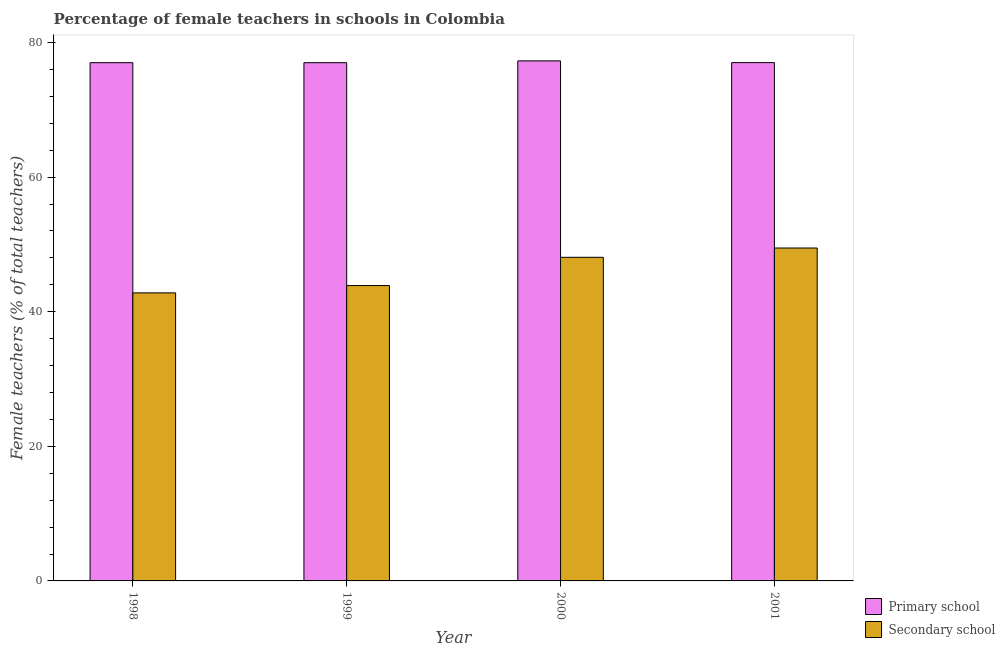How many different coloured bars are there?
Offer a terse response. 2. How many groups of bars are there?
Your response must be concise. 4. Are the number of bars per tick equal to the number of legend labels?
Offer a very short reply. Yes. Are the number of bars on each tick of the X-axis equal?
Provide a short and direct response. Yes. How many bars are there on the 1st tick from the right?
Your response must be concise. 2. What is the percentage of female teachers in primary schools in 2000?
Provide a short and direct response. 77.27. Across all years, what is the maximum percentage of female teachers in secondary schools?
Offer a terse response. 49.47. Across all years, what is the minimum percentage of female teachers in secondary schools?
Offer a terse response. 42.8. What is the total percentage of female teachers in secondary schools in the graph?
Your response must be concise. 184.24. What is the difference between the percentage of female teachers in secondary schools in 1998 and that in 1999?
Offer a terse response. -1.09. What is the difference between the percentage of female teachers in secondary schools in 2001 and the percentage of female teachers in primary schools in 1999?
Provide a succinct answer. 5.58. What is the average percentage of female teachers in secondary schools per year?
Offer a very short reply. 46.06. What is the ratio of the percentage of female teachers in secondary schools in 1998 to that in 1999?
Your response must be concise. 0.98. What is the difference between the highest and the second highest percentage of female teachers in secondary schools?
Your answer should be compact. 1.38. What is the difference between the highest and the lowest percentage of female teachers in primary schools?
Offer a very short reply. 0.27. In how many years, is the percentage of female teachers in primary schools greater than the average percentage of female teachers in primary schools taken over all years?
Your response must be concise. 1. What does the 1st bar from the left in 2000 represents?
Ensure brevity in your answer.  Primary school. What does the 2nd bar from the right in 1999 represents?
Make the answer very short. Primary school. How many bars are there?
Offer a very short reply. 8. Are all the bars in the graph horizontal?
Keep it short and to the point. No. How many years are there in the graph?
Ensure brevity in your answer.  4. Are the values on the major ticks of Y-axis written in scientific E-notation?
Offer a terse response. No. Does the graph contain any zero values?
Make the answer very short. No. Does the graph contain grids?
Your response must be concise. No. How many legend labels are there?
Provide a short and direct response. 2. How are the legend labels stacked?
Offer a very short reply. Vertical. What is the title of the graph?
Give a very brief answer. Percentage of female teachers in schools in Colombia. What is the label or title of the X-axis?
Make the answer very short. Year. What is the label or title of the Y-axis?
Give a very brief answer. Female teachers (% of total teachers). What is the Female teachers (% of total teachers) of Primary school in 1998?
Your response must be concise. 77. What is the Female teachers (% of total teachers) of Secondary school in 1998?
Offer a terse response. 42.8. What is the Female teachers (% of total teachers) in Primary school in 1999?
Provide a succinct answer. 77. What is the Female teachers (% of total teachers) in Secondary school in 1999?
Provide a succinct answer. 43.89. What is the Female teachers (% of total teachers) of Primary school in 2000?
Keep it short and to the point. 77.27. What is the Female teachers (% of total teachers) in Secondary school in 2000?
Your answer should be compact. 48.09. What is the Female teachers (% of total teachers) of Primary school in 2001?
Give a very brief answer. 77.02. What is the Female teachers (% of total teachers) in Secondary school in 2001?
Keep it short and to the point. 49.47. Across all years, what is the maximum Female teachers (% of total teachers) in Primary school?
Make the answer very short. 77.27. Across all years, what is the maximum Female teachers (% of total teachers) in Secondary school?
Give a very brief answer. 49.47. Across all years, what is the minimum Female teachers (% of total teachers) of Primary school?
Give a very brief answer. 77. Across all years, what is the minimum Female teachers (% of total teachers) of Secondary school?
Your answer should be very brief. 42.8. What is the total Female teachers (% of total teachers) in Primary school in the graph?
Provide a short and direct response. 308.3. What is the total Female teachers (% of total teachers) in Secondary school in the graph?
Your answer should be very brief. 184.24. What is the difference between the Female teachers (% of total teachers) of Primary school in 1998 and that in 1999?
Your answer should be very brief. 0. What is the difference between the Female teachers (% of total teachers) of Secondary school in 1998 and that in 1999?
Your answer should be very brief. -1.09. What is the difference between the Female teachers (% of total teachers) of Primary school in 1998 and that in 2000?
Offer a very short reply. -0.27. What is the difference between the Female teachers (% of total teachers) of Secondary school in 1998 and that in 2000?
Offer a very short reply. -5.29. What is the difference between the Female teachers (% of total teachers) of Primary school in 1998 and that in 2001?
Ensure brevity in your answer.  -0.01. What is the difference between the Female teachers (% of total teachers) in Secondary school in 1998 and that in 2001?
Give a very brief answer. -6.67. What is the difference between the Female teachers (% of total teachers) of Primary school in 1999 and that in 2000?
Provide a succinct answer. -0.27. What is the difference between the Female teachers (% of total teachers) of Secondary school in 1999 and that in 2000?
Your answer should be compact. -4.2. What is the difference between the Female teachers (% of total teachers) in Primary school in 1999 and that in 2001?
Offer a terse response. -0.01. What is the difference between the Female teachers (% of total teachers) in Secondary school in 1999 and that in 2001?
Give a very brief answer. -5.58. What is the difference between the Female teachers (% of total teachers) in Primary school in 2000 and that in 2001?
Keep it short and to the point. 0.26. What is the difference between the Female teachers (% of total teachers) in Secondary school in 2000 and that in 2001?
Your answer should be very brief. -1.38. What is the difference between the Female teachers (% of total teachers) of Primary school in 1998 and the Female teachers (% of total teachers) of Secondary school in 1999?
Your answer should be compact. 33.12. What is the difference between the Female teachers (% of total teachers) in Primary school in 1998 and the Female teachers (% of total teachers) in Secondary school in 2000?
Provide a short and direct response. 28.92. What is the difference between the Female teachers (% of total teachers) of Primary school in 1998 and the Female teachers (% of total teachers) of Secondary school in 2001?
Offer a terse response. 27.54. What is the difference between the Female teachers (% of total teachers) of Primary school in 1999 and the Female teachers (% of total teachers) of Secondary school in 2000?
Your response must be concise. 28.92. What is the difference between the Female teachers (% of total teachers) in Primary school in 1999 and the Female teachers (% of total teachers) in Secondary school in 2001?
Provide a short and direct response. 27.54. What is the difference between the Female teachers (% of total teachers) of Primary school in 2000 and the Female teachers (% of total teachers) of Secondary school in 2001?
Offer a terse response. 27.81. What is the average Female teachers (% of total teachers) of Primary school per year?
Your answer should be compact. 77.07. What is the average Female teachers (% of total teachers) of Secondary school per year?
Offer a terse response. 46.06. In the year 1998, what is the difference between the Female teachers (% of total teachers) in Primary school and Female teachers (% of total teachers) in Secondary school?
Your response must be concise. 34.2. In the year 1999, what is the difference between the Female teachers (% of total teachers) of Primary school and Female teachers (% of total teachers) of Secondary school?
Offer a very short reply. 33.12. In the year 2000, what is the difference between the Female teachers (% of total teachers) in Primary school and Female teachers (% of total teachers) in Secondary school?
Your answer should be compact. 29.19. In the year 2001, what is the difference between the Female teachers (% of total teachers) of Primary school and Female teachers (% of total teachers) of Secondary school?
Your answer should be compact. 27.55. What is the ratio of the Female teachers (% of total teachers) in Primary school in 1998 to that in 1999?
Make the answer very short. 1. What is the ratio of the Female teachers (% of total teachers) in Secondary school in 1998 to that in 1999?
Offer a terse response. 0.98. What is the ratio of the Female teachers (% of total teachers) in Secondary school in 1998 to that in 2000?
Keep it short and to the point. 0.89. What is the ratio of the Female teachers (% of total teachers) of Primary school in 1998 to that in 2001?
Your response must be concise. 1. What is the ratio of the Female teachers (% of total teachers) in Secondary school in 1998 to that in 2001?
Give a very brief answer. 0.87. What is the ratio of the Female teachers (% of total teachers) in Secondary school in 1999 to that in 2000?
Keep it short and to the point. 0.91. What is the ratio of the Female teachers (% of total teachers) in Primary school in 1999 to that in 2001?
Give a very brief answer. 1. What is the ratio of the Female teachers (% of total teachers) of Secondary school in 1999 to that in 2001?
Offer a very short reply. 0.89. What is the ratio of the Female teachers (% of total teachers) of Primary school in 2000 to that in 2001?
Offer a very short reply. 1. What is the ratio of the Female teachers (% of total teachers) of Secondary school in 2000 to that in 2001?
Offer a very short reply. 0.97. What is the difference between the highest and the second highest Female teachers (% of total teachers) of Primary school?
Your response must be concise. 0.26. What is the difference between the highest and the second highest Female teachers (% of total teachers) of Secondary school?
Keep it short and to the point. 1.38. What is the difference between the highest and the lowest Female teachers (% of total teachers) of Primary school?
Your response must be concise. 0.27. What is the difference between the highest and the lowest Female teachers (% of total teachers) in Secondary school?
Your answer should be very brief. 6.67. 